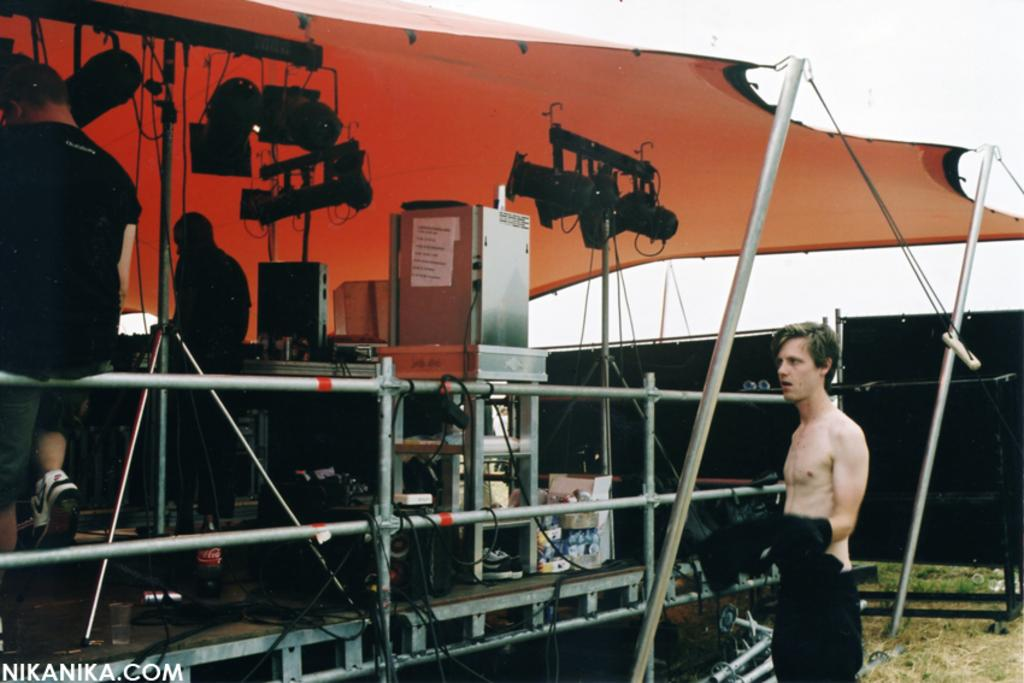How many people are visible in the image? There are persons in the image, but the exact number is not specified. What can be seen illuminating the scene in the image? There are lights in the image. What is located on the stage in the image? There are objects on the stage. What structure is present at the top of the image? There is a tent at the top of the image. Where is another person located in the image? There is another person in the bottom right of the image. What is the title of the plastic hour depicted in the image? There is no mention of a title, plastic, or hour in the image. 